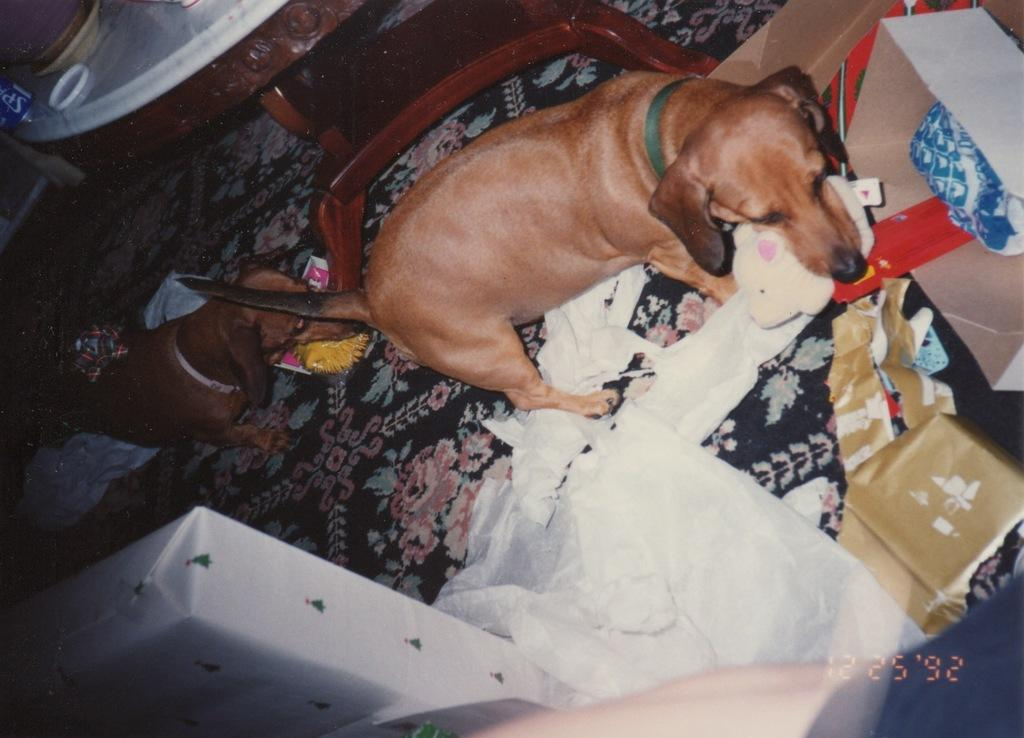What type of living organisms are present in the image? There are animals in the image. Where are the animals located? The animals are on a surface in the image. What type of furniture is visible in the image? There is a wooden table in the image. What else can be seen on the table besides the wooden surface? There are objects on the table in the image. How many cherries are hanging from the kite in the image? There is no kite or cherries present in the image. Is there a tub filled with water near the animals in the image? There is no tub or water visible in the image. 